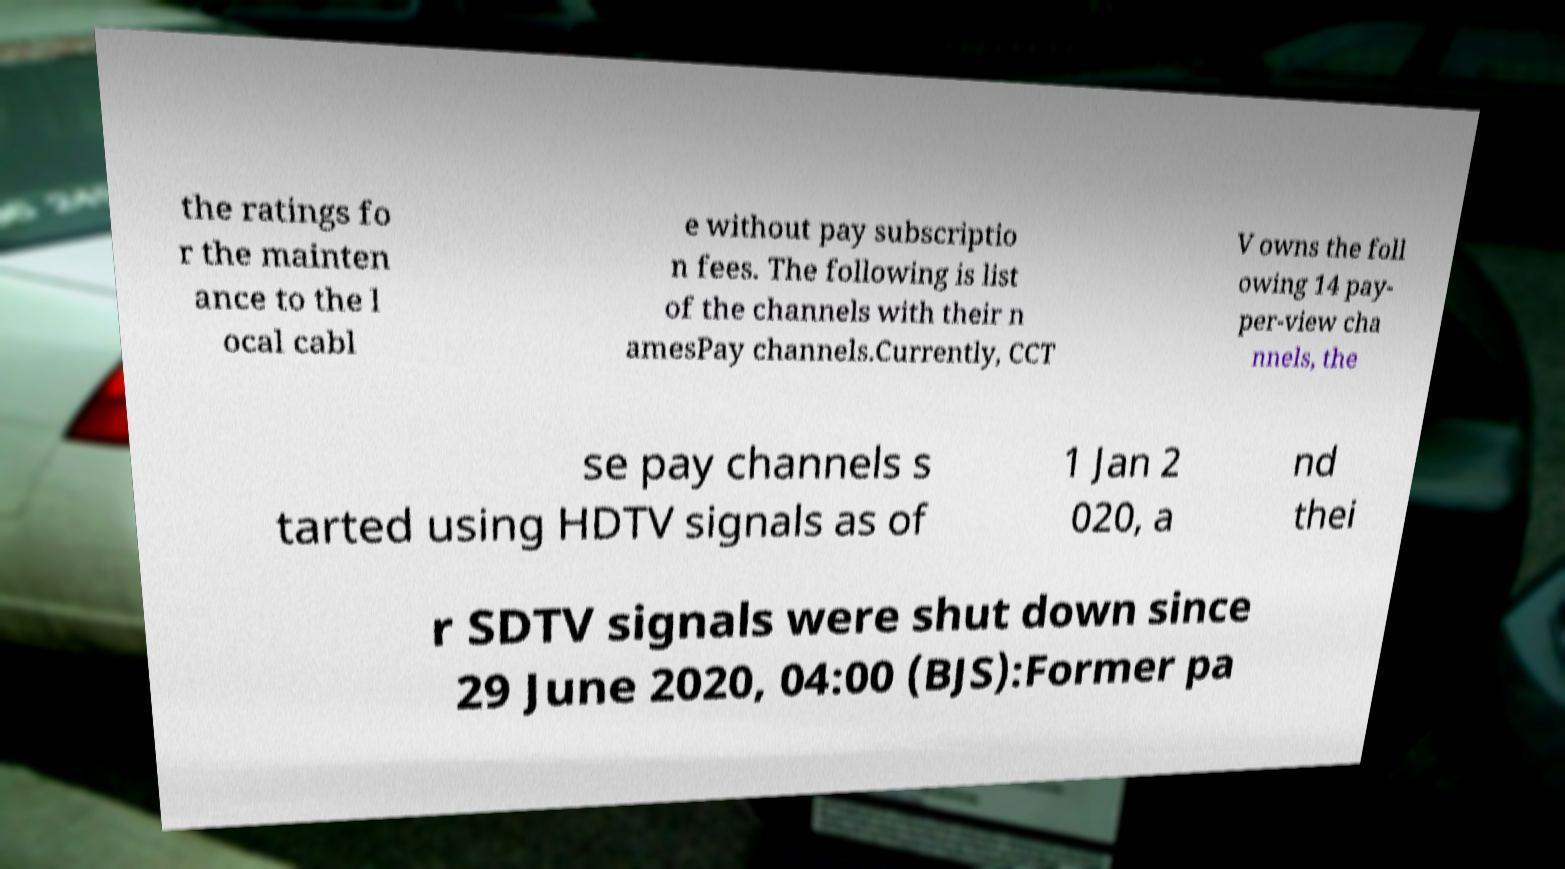What messages or text are displayed in this image? I need them in a readable, typed format. the ratings fo r the mainten ance to the l ocal cabl e without pay subscriptio n fees. The following is list of the channels with their n amesPay channels.Currently, CCT V owns the foll owing 14 pay- per-view cha nnels, the se pay channels s tarted using HDTV signals as of 1 Jan 2 020, a nd thei r SDTV signals were shut down since 29 June 2020, 04:00 (BJS):Former pa 